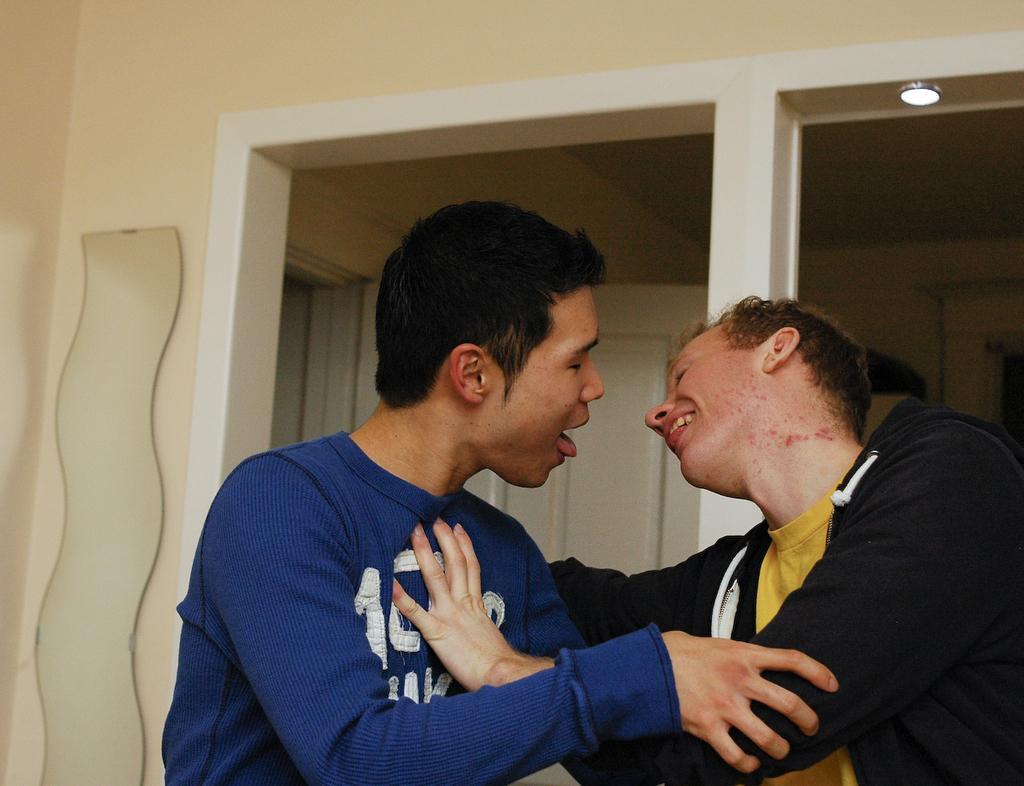Describe this image in one or two sentences. On the left side, there is a person in violet color T-shirt having opened his mouth and holding the hand of a person who is in a black color jacket and is placing his hand on the chest of that person and smiling. In the background, there is a light attached to the roof, there is a wall and there is a door. 